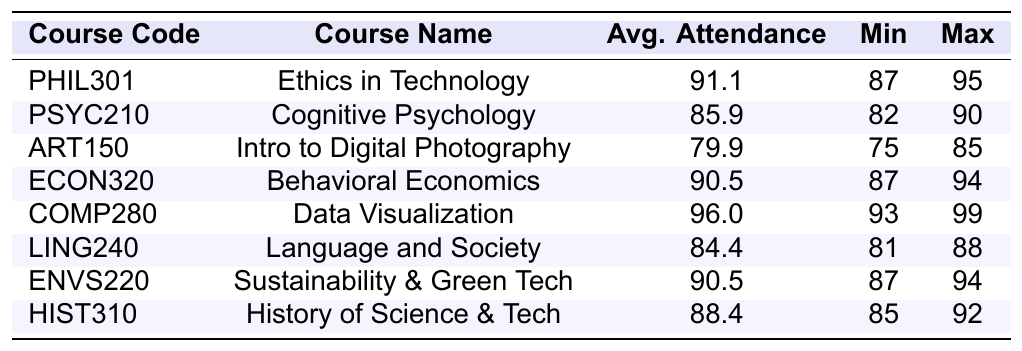What is the average attendance for the course "Data Visualization"? According to the table, "Data Visualization" has an average attendance of 96.0.
Answer: 96.0 Which course has the highest minimum attendance? The course with the highest minimum attendance is "Ethics in Technology," with a minimum attendance of 87.
Answer: Ethics in Technology What is the minimum attendance for the course "Sustainability and Green Technology"? The minimum attendance for "Sustainability and Green Technology" is 87, as stated in the table.
Answer: 87 True or false: The average attendance for "Cognitive Psychology" is above 86. The average attendance for "Cognitive Psychology" is 85.9, which is not above 86, making the statement false.
Answer: False What are the average attendances of "Behavioral Economics" and "Sustainability and Green Technology"? The average attendance for "Behavioral Economics" is 90.5 and for "Sustainability and Green Technology" it is also 90.5.
Answer: 90.5 and 90.5 How much higher is the maximum attendance of "Data Visualization" compared to "Introduction to Digital Photography"? The maximum attendance for "Data Visualization" is 99, while for "Introduction to Digital Photography" it is 85. Therefore, 99 - 85 = 14.
Answer: 14 Which course(s) have an average attendance below 80? The only course with an average attendance below 80 is "Introduction to Digital Photography," which has an average of 79.9.
Answer: Introduction to Digital Photography What was the range of attendance for "History of Science and Technology"? The range is calculated by subtracting the minimum attendance (85) from the maximum attendance (92), giving us 92 - 85 = 7.
Answer: 7 Which two courses have the same average attendance value, and what is that value? "Behavioral Economics" and "Sustainability and Green Technology" both have an average attendance of 90.5.
Answer: 90.5 Is the average attendance for "Language and Society" greater than or equal to 85? The average attendance for "Language and Society" is 84.4, which is less than 85, making the statement false.
Answer: False 